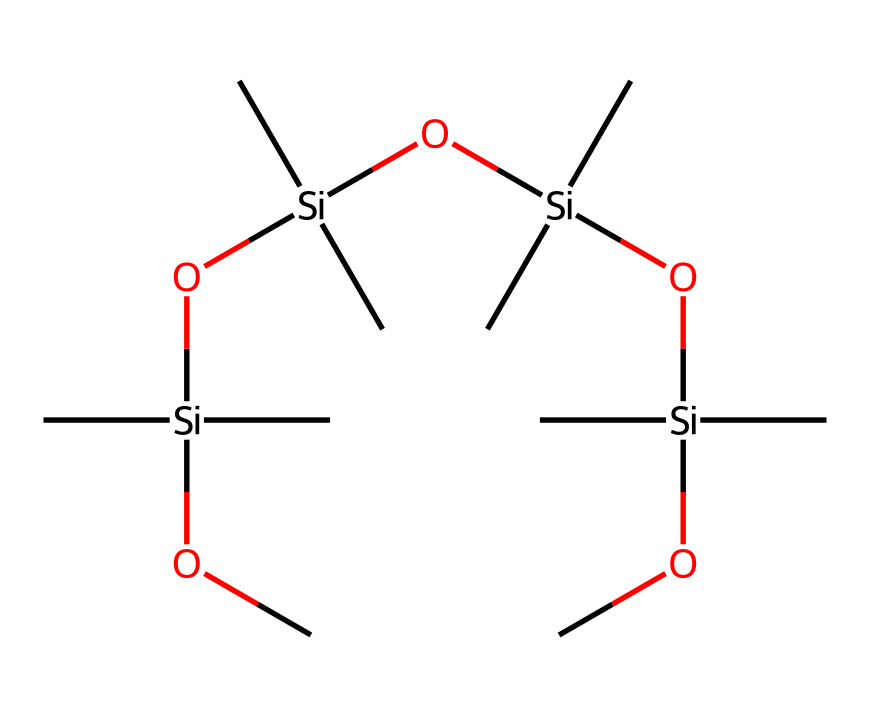What is the main element in this compound? The structure includes silicon (Si) atoms prominently located at the center of the formula, indicating that silicon is the primary element present.
Answer: silicon How many carbon atoms are in the molecule? By examining the SMILES representation, there are 12 carbon atoms (C) surrounding the silicon atoms, counted by noting each 'C' located in the structure.
Answer: 12 What functional group is represented in the molecule? The presence of the terminal 'O' atoms indicates the molecule contains silanol (Si-OH) and siloxane (Si-O-Si) functional groups, typical in silicone compounds.
Answer: siloxane What is the maximum degree of branching in the molecule? The notation indicates that each silicon atom is bonded to three carbon atoms and/or oxygen atoms, showing multiple branches off each silicon atom, hence a maximum branching of 3.
Answer: 3 How many silanol groups are present in this structure? The structure shows terminal 'O' connected to 'Si' without further carbon bonding, indicating there are two instances of silanol groups in the molecular structure.
Answer: 2 What type of chemical is this? Based on the silicon and carbon configuration, this is classified as an organosilicon compound, typically known for its lubricating properties in various applications including automotive.
Answer: organosilicon 